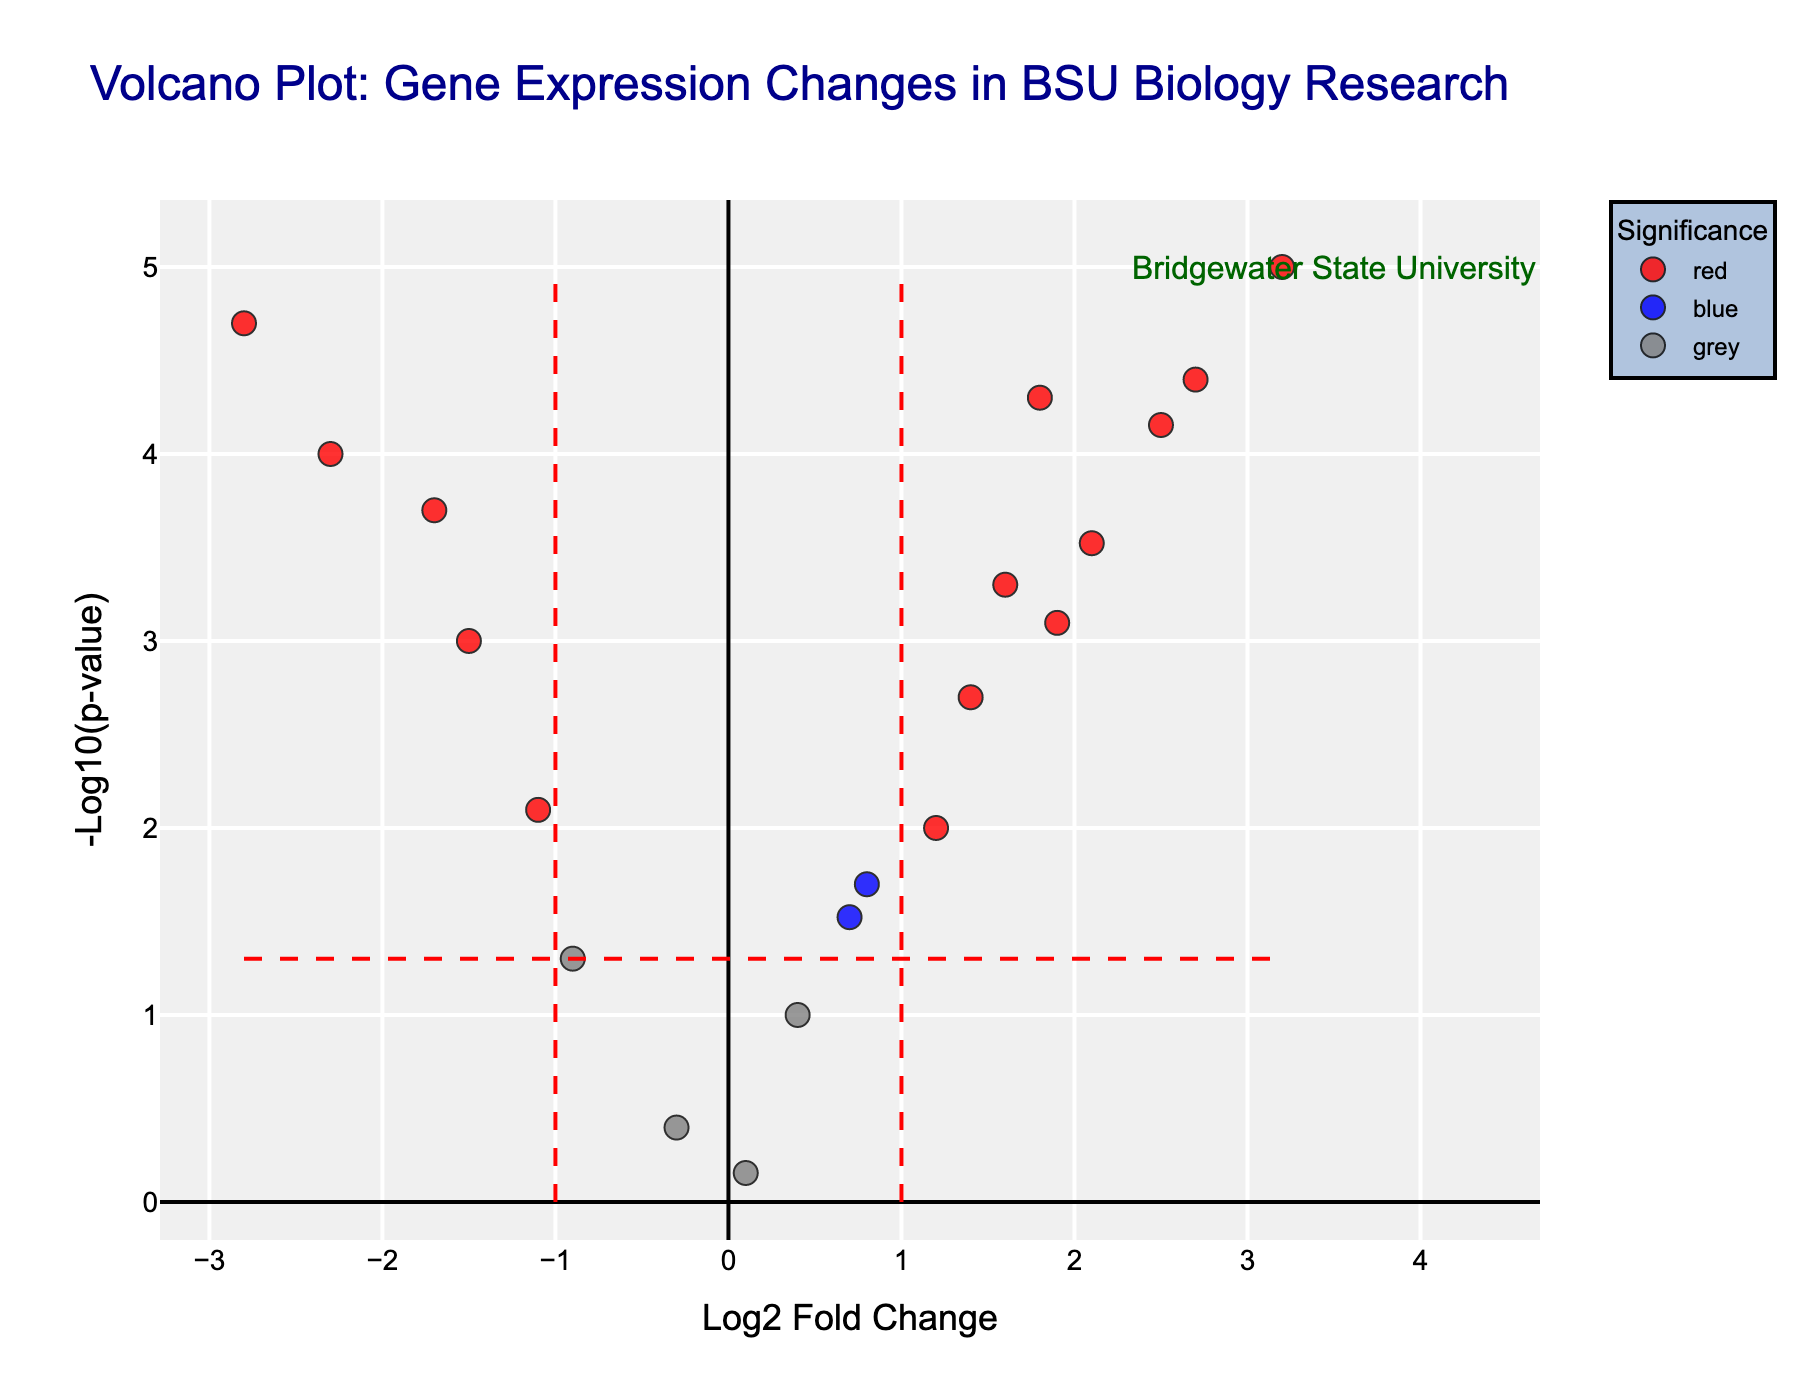what is the title of the figure? The title of the figure is usually displayed prominently above the plot. In this case, it is located at the top center of the Volcano Plot.
Answer: Volcano Plot: Gene Expression Changes in BSU Biology Research How many genes have a p-value less than 0.05? Look at the horizontal line at y-axis value -log10(p-value) where p-value is 0.05. Count the number of points above this line.
Answer: 16 Which gene has the highest -log10(p-value) and what is its log2 fold change value? Find the point that is the highest on the y-axis (-log10(p-value)). The gene name will be shown next to it. Check its x-axis value (log2 fold change).
Answer: IL6, 3.2 Which color represents genes with significant log2_fold_change and p-values? The color coding is defined such that red color corresponds to genes with both log2_fold_change > 1 or < -1 and p-value < 0.05.
Answer: red Which gene shows the most negative log2 fold change with a significant p-value? Look at the points in the plot. Find the most leftward red marker, which means the highest negative value on the x-axis with the color red.
Answer: CDKN2A, -2.8 Are there any genes with log2 fold change between -1 and 1 but with significant p-values? Look within the x-axis range -1 to 1 and identify points colored blue, which denote significant p-values but non-significant fold changes.
Answer: Yes, APOE, MYC, NFKB1 Which genes are identified as green in the plot? Green points represent genes with significant fold changes (log2_fold_change > 1 or < -1) but non-significant p-values (p-value >= 0.05). Identify green points in the plot.
Answer: None Compare the fold change of TP53 and EGFR. Which one has a higher fold change? Locate the points for TP53 and EGFR. Compare their x-axis positions to determine which is further right and thus has a higher log2 fold change.
Answer: EGFR, 2.1 How many genes have a log2 fold change greater than 2 and a p-value less than 0.001? Identify points in the plot to the right of x-axis value 2 and above -log10(0.001) on the y-axis. Count these points.
Answer: 3 What is the significance of the vertical dashed line at x=1 and x=-1? The vertical dashed lines indicate a threshold for log2 fold changes where values beyond these lines (i.e., > 1 or < -1) are considered significant.
Answer: Log2 fold change significance thresholds 